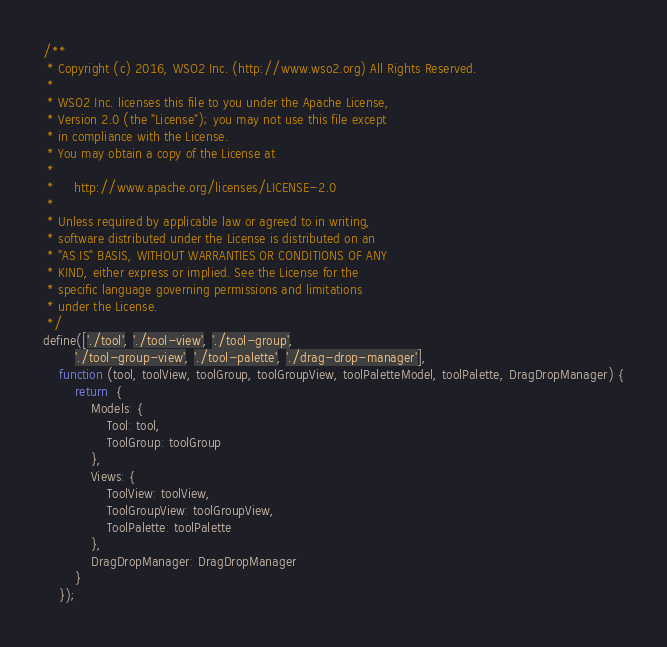<code> <loc_0><loc_0><loc_500><loc_500><_JavaScript_>/**
 * Copyright (c) 2016, WSO2 Inc. (http://www.wso2.org) All Rights Reserved.
 *
 * WSO2 Inc. licenses this file to you under the Apache License,
 * Version 2.0 (the "License"); you may not use this file except
 * in compliance with the License.
 * You may obtain a copy of the License at
 *
 *     http://www.apache.org/licenses/LICENSE-2.0
 *
 * Unless required by applicable law or agreed to in writing,
 * software distributed under the License is distributed on an
 * "AS IS" BASIS, WITHOUT WARRANTIES OR CONDITIONS OF ANY
 * KIND, either express or implied. See the License for the
 * specific language governing permissions and limitations
 * under the License.
 */
define(['./tool', './tool-view', './tool-group',
        './tool-group-view', './tool-palette', './drag-drop-manager'],
    function (tool, toolView, toolGroup, toolGroupView, toolPaletteModel, toolPalette, DragDropManager) {
        return  {
            Models: {
                Tool: tool,
                ToolGroup: toolGroup
            },
            Views: {
                ToolView: toolView,
                ToolGroupView: toolGroupView,
                ToolPalette: toolPalette
            },
            DragDropManager: DragDropManager
        }
    });

</code> 